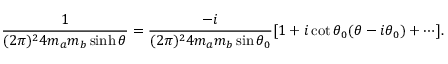Convert formula to latex. <formula><loc_0><loc_0><loc_500><loc_500>\frac { 1 } { ( 2 \pi ) ^ { 2 } 4 m _ { a } m _ { b } \sinh \theta } = \frac { - i } { ( 2 \pi ) ^ { 2 } 4 m _ { a } m _ { b } \sin \theta _ { 0 } } [ 1 + i \cot \theta _ { 0 } ( \theta - i \theta _ { 0 } ) + \cdots ] .</formula> 